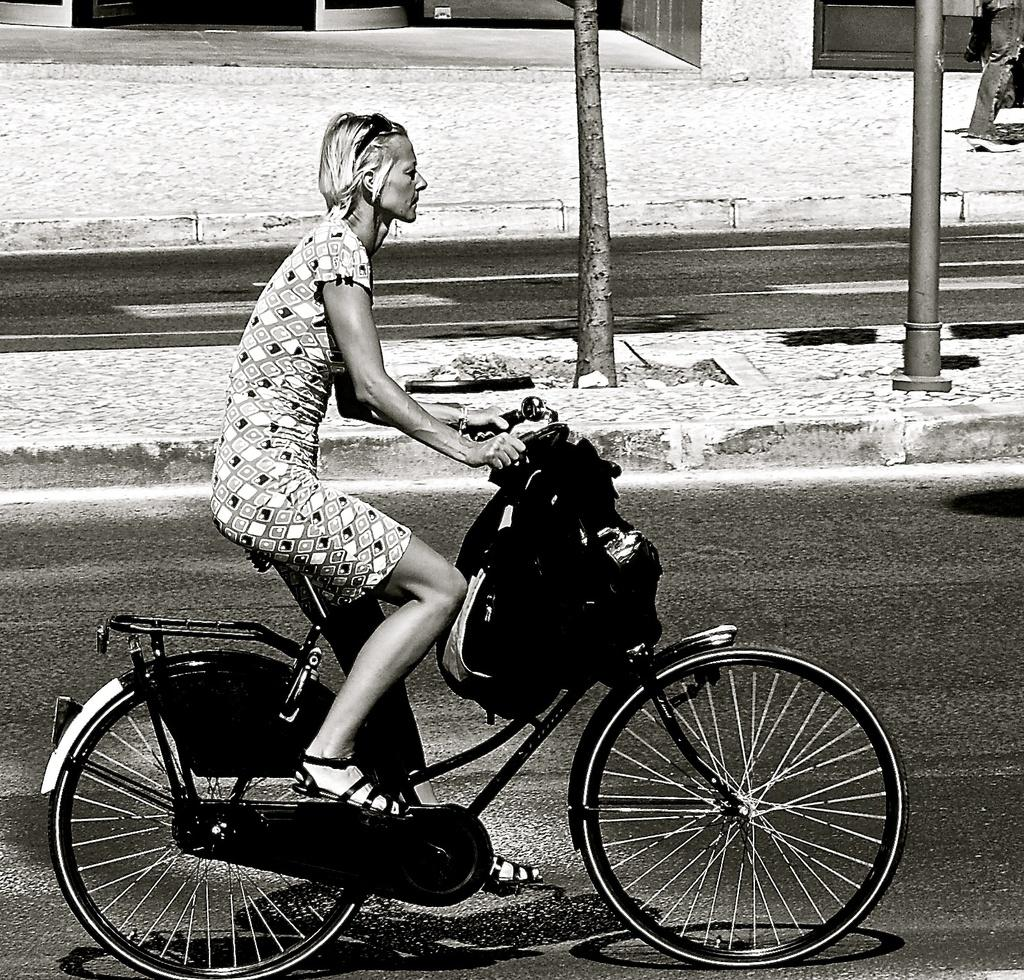What is the main subject of the image? There is a person in the image. What is the person doing in the image? The person is riding a bicycle. What can be seen to the left of the person? There is a branch of a tree to the left of the person. What other object is present in the image? There is a pole in the image. What event is the person's mind attending in the image? There is no indication in the image that the person's mind is attending any event. 